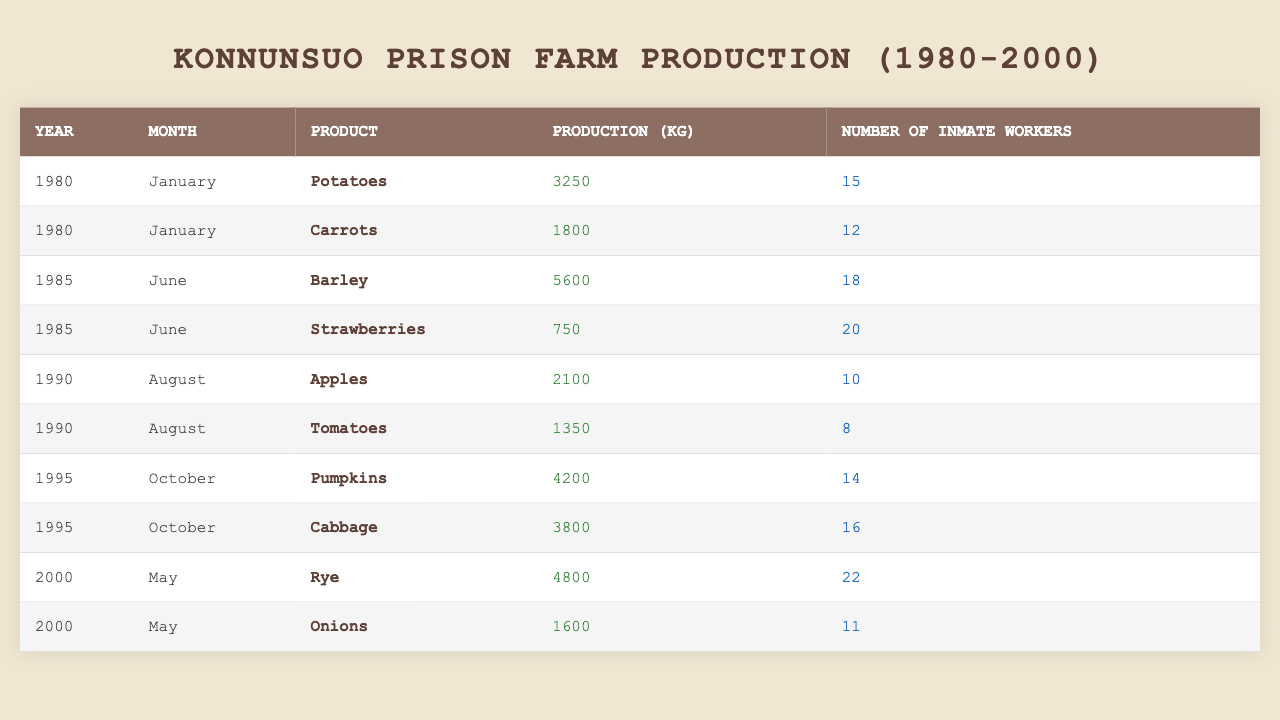What was the total production of Potatoes in January 1980? The table shows that in January 1980, the production of Potatoes was 3250 kg. As only one entry exists for this product in that month, the total is simply 3250 kg.
Answer: 3250 kg How many inmate workers were involved in producing Carrots in January 1980? The table indicates that there were 12 inmate workers involved in the production of Carrots in January 1980, as it lists that number directly next to the Carrots entry.
Answer: 12 What is the total production of fruits (Apples and Strawberries) in 1990? The table includes Apples with a production of 2100 kg and does not list Strawberries for 1990 but lists them for June 1985. Therefore, the total production for fruits in 1990 consists only of Apples, which is 2100 kg.
Answer: 2100 kg What was the highest production recorded in the year 1995? The table shows two products for October 1995: Pumpkins with 4200 kg and Cabbage with 3800 kg. Among these, the highest production is for Pumpkins at 4200 kg.
Answer: 4200 kg How many different crops were produced in the year 2000? In the year 2000, the table shows two entries: Rye and Onions. Thus, there were 2 different crops produced that year.
Answer: 2 Which month had the least number of inmate workers for the products listed? Reviewing the inmate workers across all months, the least number is in August 1990 for Tomatoes with 8 workers.
Answer: 8 What is the average production (in kg) of Barley and Strawberries in June 1985? In June 1985, Barley was produced at 5600 kg and Strawberries at 750 kg. Calculating the average: (5600 + 750) / 2 = 6350 / 2 = 3175 kg.
Answer: 3175 kg Was there any month in the table where only one product was produced? By examining each month in the table, February and other months have multiple products recorded. Each month listed has at least two products; thus, the answer is no.
Answer: No In what year did the production of Pumpkins occur, and how many kg were produced? The table shows that Pumpkins were produced in October 1995 with a total production of 4200 kg listed directly next to it.
Answer: 1995, 4200 kg Which product had the highest number of inmate workers in the year 2000? In May 2000, the highest number of inmate workers is for Rye, which had 22 workers, while Onions had only 11.
Answer: Rye, 22 workers 